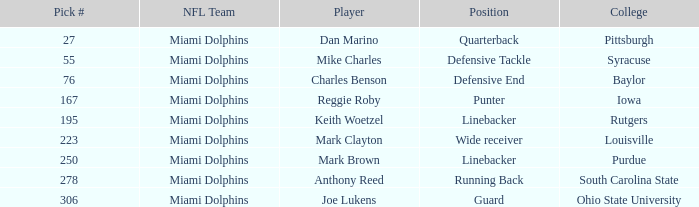Which College has Player Mark Brown and a Pick # greater than 195? Purdue. 